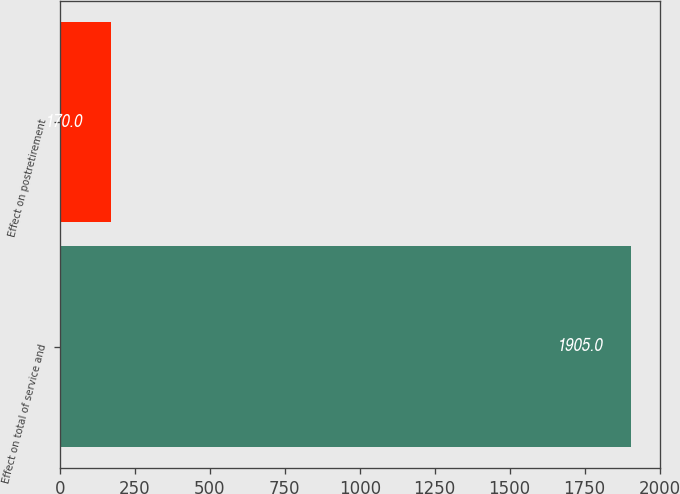<chart> <loc_0><loc_0><loc_500><loc_500><bar_chart><fcel>Effect on total of service and<fcel>Effect on postretirement<nl><fcel>1905<fcel>170<nl></chart> 